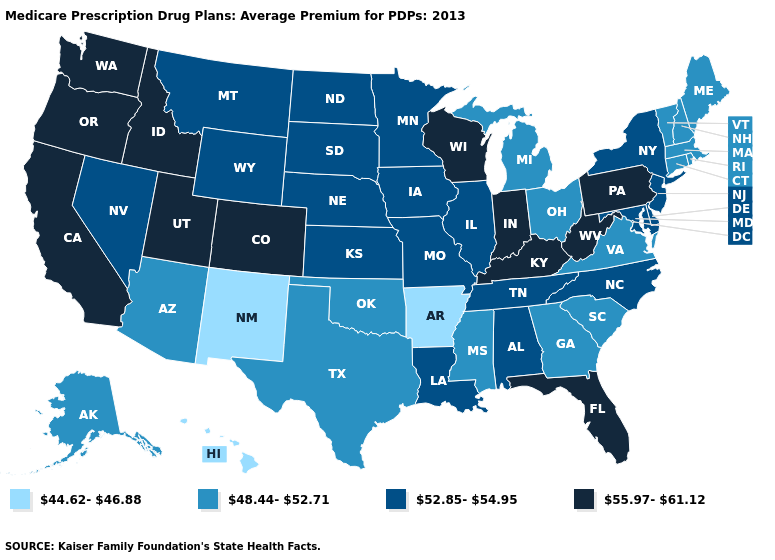Is the legend a continuous bar?
Answer briefly. No. Which states have the highest value in the USA?
Keep it brief. California, Colorado, Florida, Idaho, Indiana, Kentucky, Oregon, Pennsylvania, Utah, Washington, Wisconsin, West Virginia. Among the states that border Pennsylvania , does Ohio have the highest value?
Be succinct. No. Name the states that have a value in the range 48.44-52.71?
Be succinct. Alaska, Arizona, Connecticut, Georgia, Massachusetts, Maine, Michigan, Mississippi, New Hampshire, Ohio, Oklahoma, Rhode Island, South Carolina, Texas, Virginia, Vermont. What is the value of Michigan?
Be succinct. 48.44-52.71. What is the lowest value in states that border Ohio?
Write a very short answer. 48.44-52.71. Does New Mexico have the lowest value in the USA?
Concise answer only. Yes. Does the map have missing data?
Keep it brief. No. What is the value of Illinois?
Answer briefly. 52.85-54.95. What is the lowest value in the West?
Quick response, please. 44.62-46.88. What is the value of North Carolina?
Quick response, please. 52.85-54.95. Name the states that have a value in the range 55.97-61.12?
Quick response, please. California, Colorado, Florida, Idaho, Indiana, Kentucky, Oregon, Pennsylvania, Utah, Washington, Wisconsin, West Virginia. Is the legend a continuous bar?
Concise answer only. No. Among the states that border Florida , which have the highest value?
Keep it brief. Alabama. Name the states that have a value in the range 52.85-54.95?
Quick response, please. Alabama, Delaware, Iowa, Illinois, Kansas, Louisiana, Maryland, Minnesota, Missouri, Montana, North Carolina, North Dakota, Nebraska, New Jersey, Nevada, New York, South Dakota, Tennessee, Wyoming. 